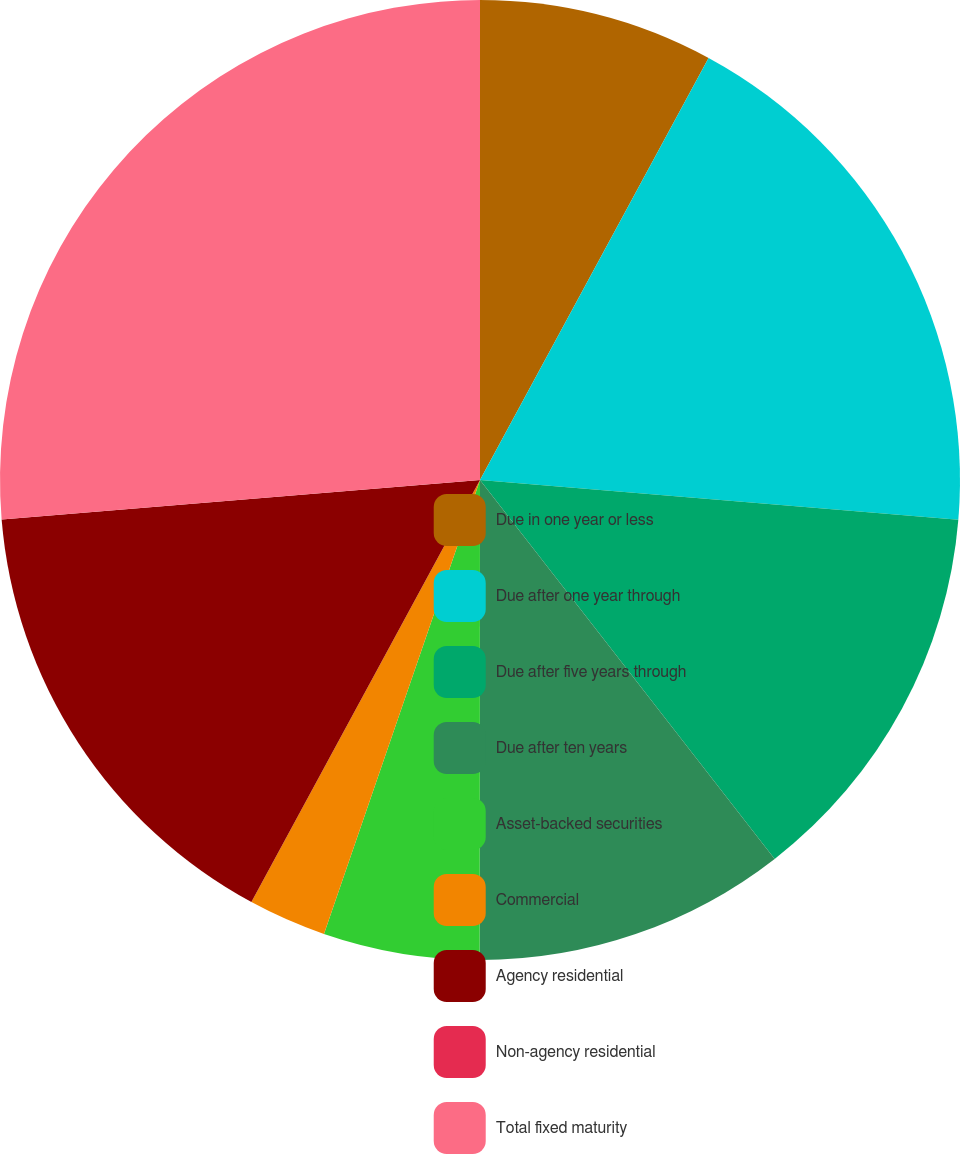Convert chart. <chart><loc_0><loc_0><loc_500><loc_500><pie_chart><fcel>Due in one year or less<fcel>Due after one year through<fcel>Due after five years through<fcel>Due after ten years<fcel>Asset-backed securities<fcel>Commercial<fcel>Agency residential<fcel>Non-agency residential<fcel>Total fixed maturity<nl><fcel>7.9%<fcel>18.42%<fcel>13.16%<fcel>10.53%<fcel>5.26%<fcel>2.63%<fcel>15.79%<fcel>0.0%<fcel>26.31%<nl></chart> 